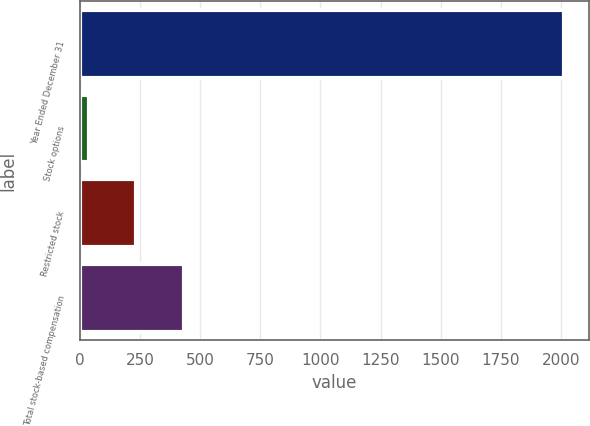Convert chart to OTSL. <chart><loc_0><loc_0><loc_500><loc_500><bar_chart><fcel>Year Ended December 31<fcel>Stock options<fcel>Restricted stock<fcel>Total stock-based compensation<nl><fcel>2014<fcel>38<fcel>235.6<fcel>433.2<nl></chart> 